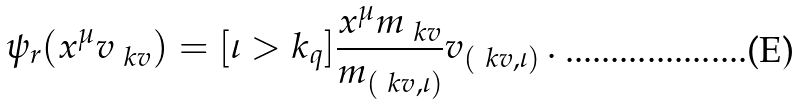Convert formula to latex. <formula><loc_0><loc_0><loc_500><loc_500>\psi _ { r } ( x ^ { \mu } v _ { \ k v } ) = [ \iota > k _ { q } ] \frac { x ^ { \mu } m _ { \ k v } } { m _ { ( \ k v , \iota ) } } v _ { ( \ k v , \iota ) } \, .</formula> 